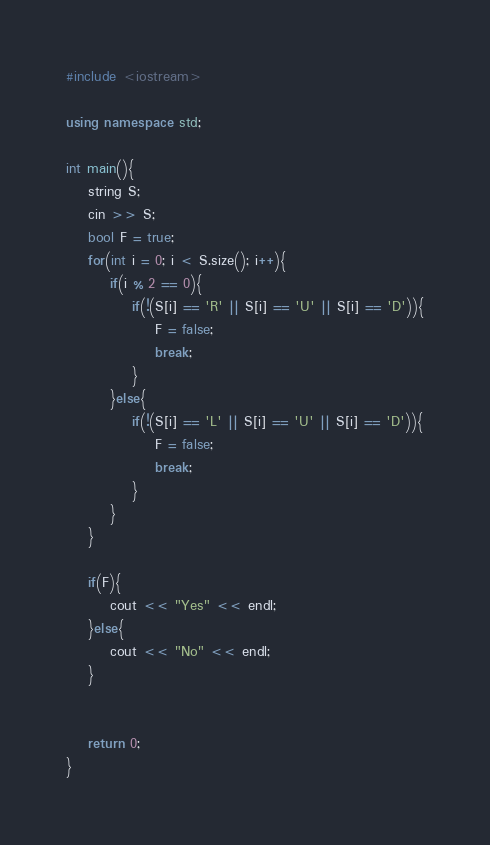<code> <loc_0><loc_0><loc_500><loc_500><_C++_>
#include <iostream>

using namespace std;

int main(){
    string S;
    cin >> S;
    bool F = true;
    for(int i = 0; i < S.size(); i++){
        if(i % 2 == 0){
            if(!(S[i] == 'R' || S[i] == 'U' || S[i] == 'D')){
                F = false;
                break;
            }
        }else{
            if(!(S[i] == 'L' || S[i] == 'U' || S[i] == 'D')){
                F = false;
                break;
            }
        }
    }

    if(F){
        cout << "Yes" << endl;
    }else{
        cout << "No" << endl;
    }

    
    return 0;
}</code> 